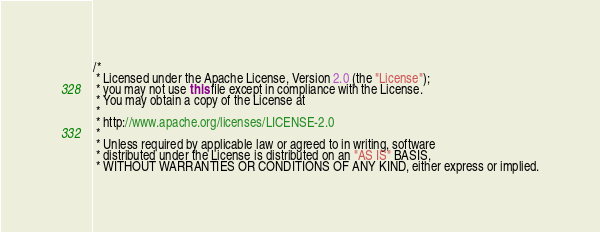<code> <loc_0><loc_0><loc_500><loc_500><_Java_>/*
 * Licensed under the Apache License, Version 2.0 (the "License");
 * you may not use this file except in compliance with the License.
 * You may obtain a copy of the License at
 *
 * http://www.apache.org/licenses/LICENSE-2.0
 *
 * Unless required by applicable law or agreed to in writing, software
 * distributed under the License is distributed on an "AS IS" BASIS,
 * WITHOUT WARRANTIES OR CONDITIONS OF ANY KIND, either express or implied.</code> 